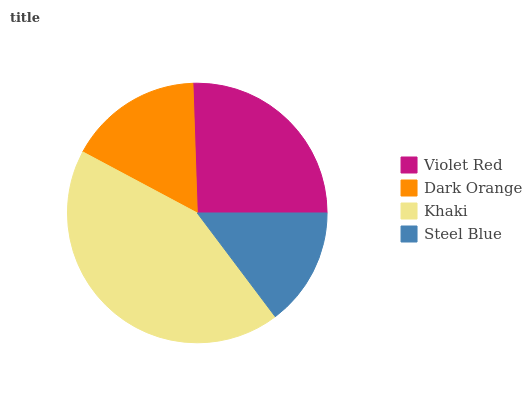Is Steel Blue the minimum?
Answer yes or no. Yes. Is Khaki the maximum?
Answer yes or no. Yes. Is Dark Orange the minimum?
Answer yes or no. No. Is Dark Orange the maximum?
Answer yes or no. No. Is Violet Red greater than Dark Orange?
Answer yes or no. Yes. Is Dark Orange less than Violet Red?
Answer yes or no. Yes. Is Dark Orange greater than Violet Red?
Answer yes or no. No. Is Violet Red less than Dark Orange?
Answer yes or no. No. Is Violet Red the high median?
Answer yes or no. Yes. Is Dark Orange the low median?
Answer yes or no. Yes. Is Khaki the high median?
Answer yes or no. No. Is Steel Blue the low median?
Answer yes or no. No. 